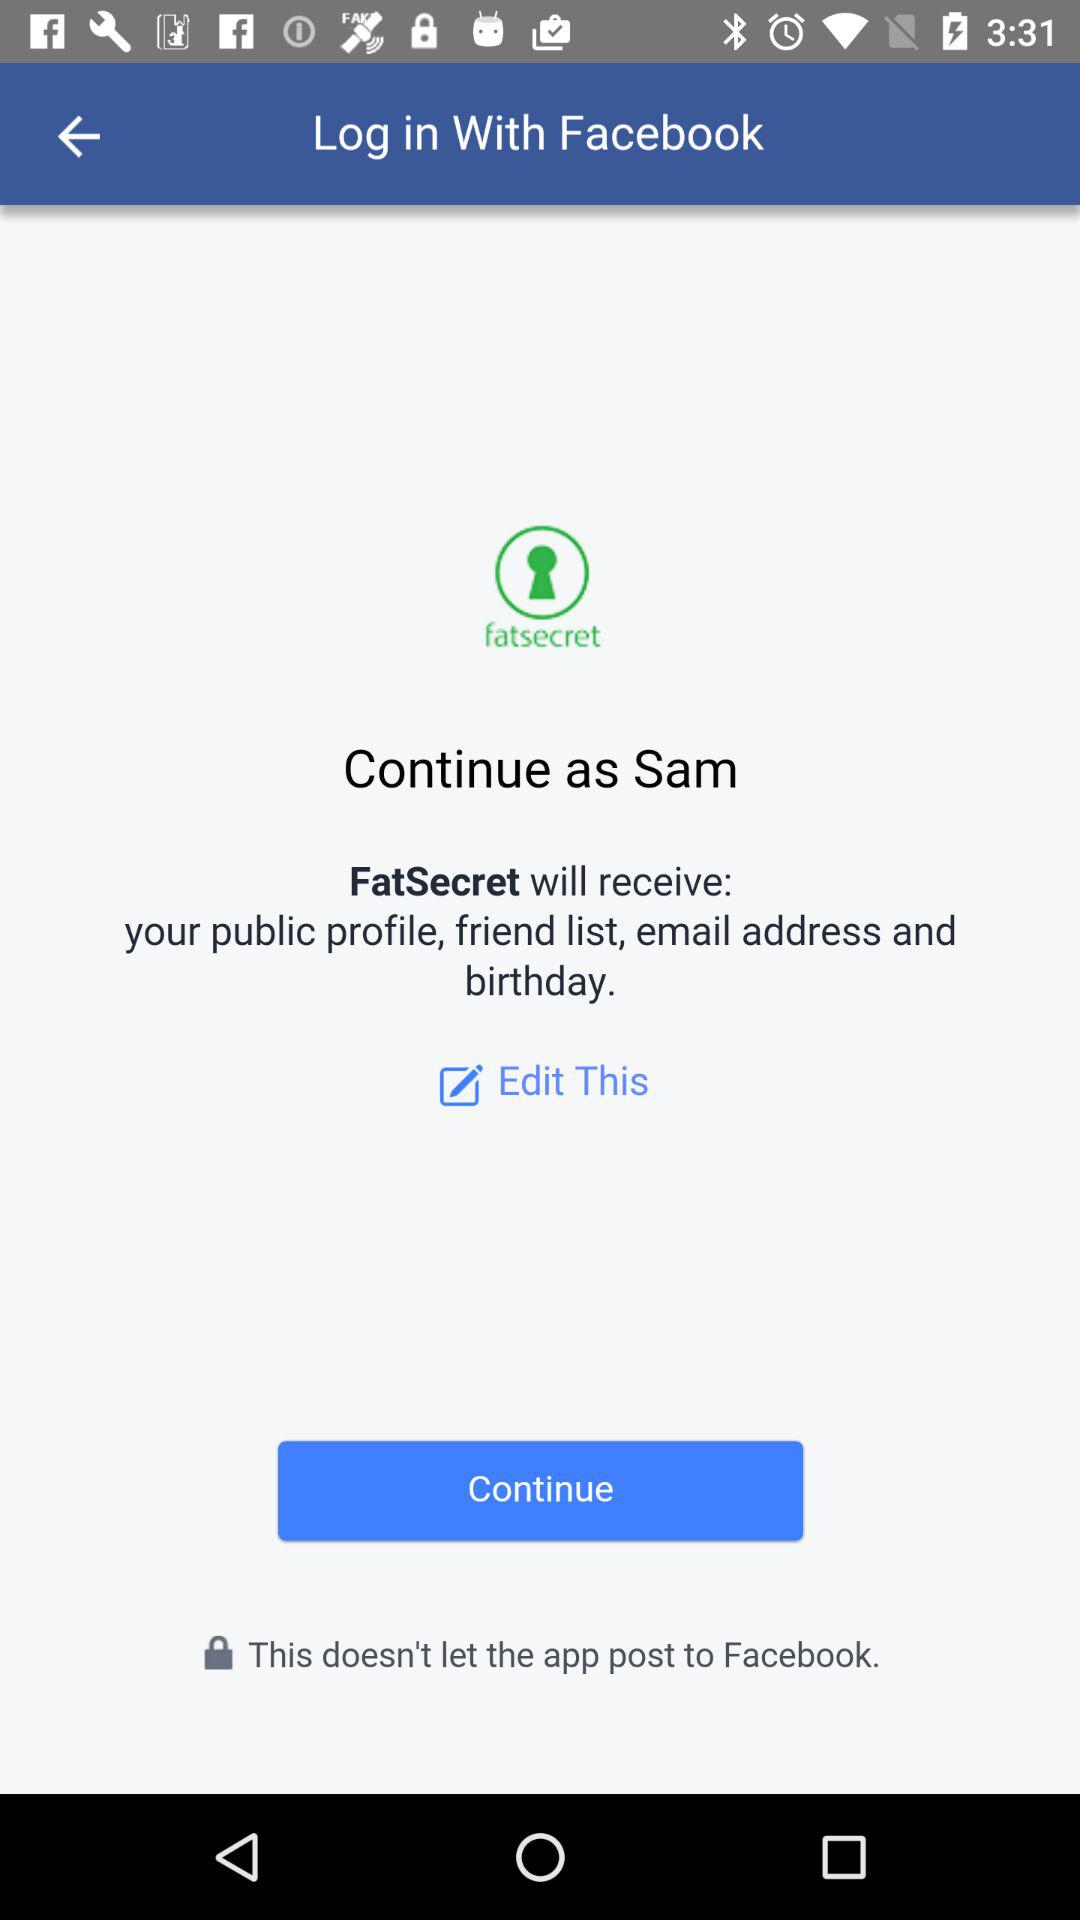What application is asking for permission? The application asking for permission is "FatSecret". 